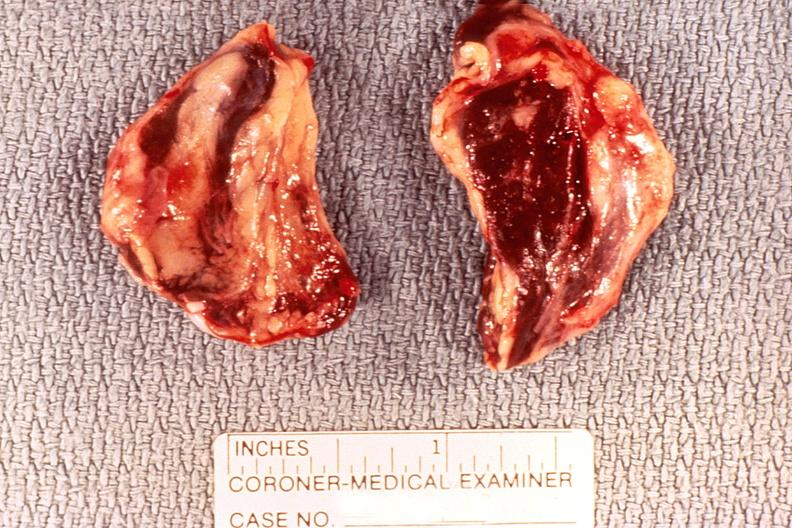what is present?
Answer the question using a single word or phrase. Endocrine 